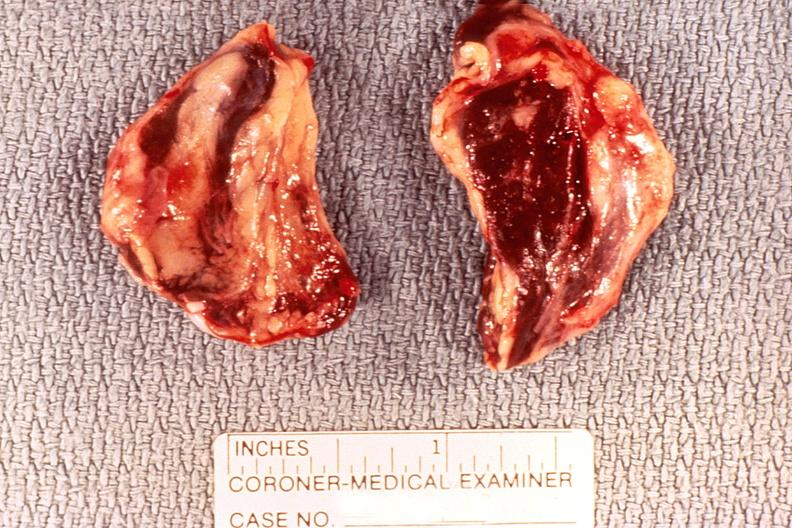what is present?
Answer the question using a single word or phrase. Endocrine 